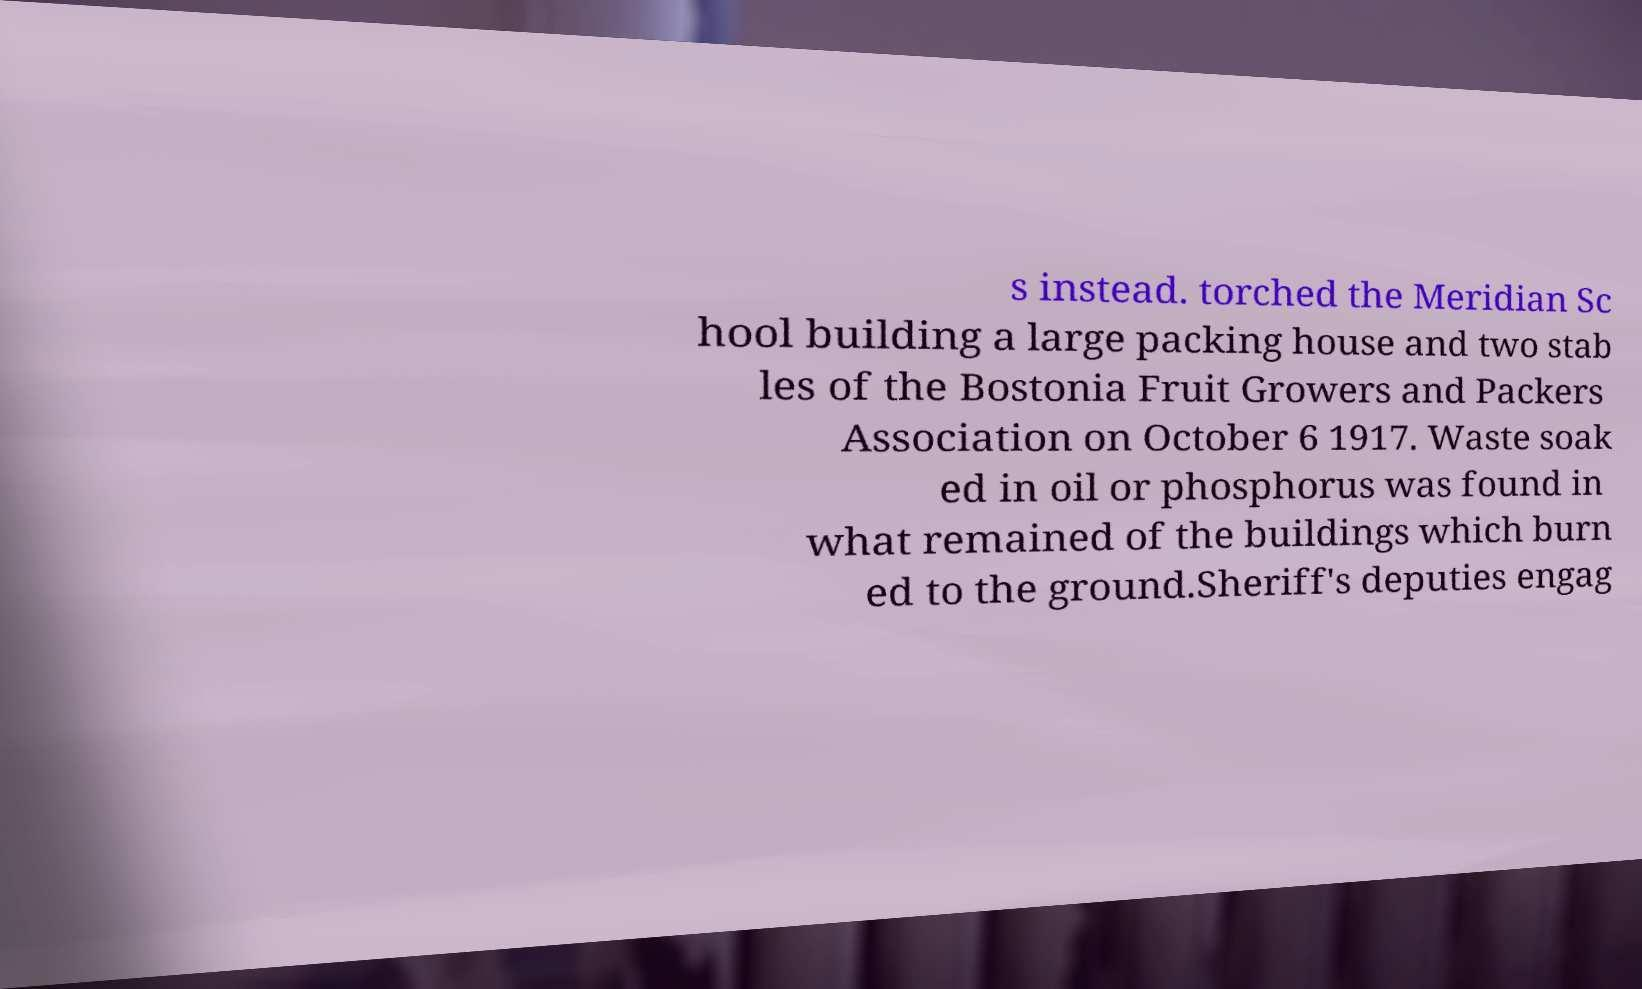What messages or text are displayed in this image? I need them in a readable, typed format. s instead. torched the Meridian Sc hool building a large packing house and two stab les of the Bostonia Fruit Growers and Packers Association on October 6 1917. Waste soak ed in oil or phosphorus was found in what remained of the buildings which burn ed to the ground.Sheriff's deputies engag 